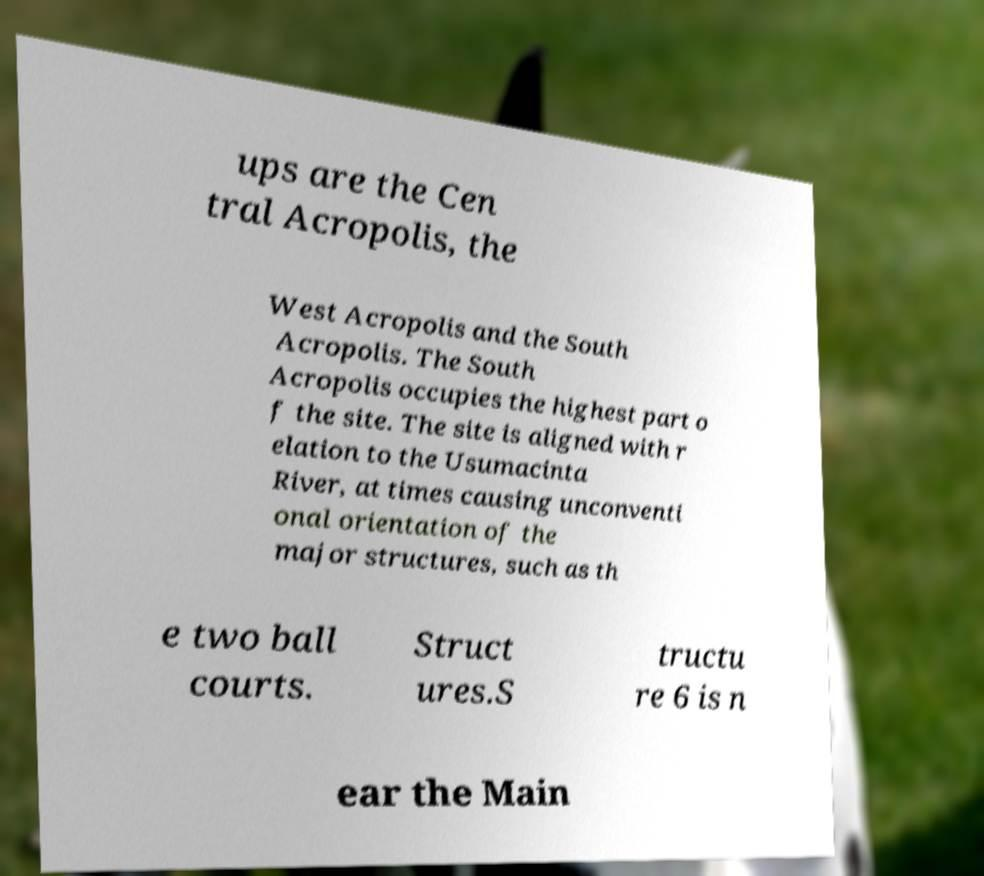There's text embedded in this image that I need extracted. Can you transcribe it verbatim? ups are the Cen tral Acropolis, the West Acropolis and the South Acropolis. The South Acropolis occupies the highest part o f the site. The site is aligned with r elation to the Usumacinta River, at times causing unconventi onal orientation of the major structures, such as th e two ball courts. Struct ures.S tructu re 6 is n ear the Main 